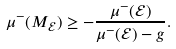<formula> <loc_0><loc_0><loc_500><loc_500>\mu ^ { - } ( M _ { \mathcal { E } } ) \geq - \frac { \mu ^ { - } ( \mathcal { E } ) } { \mu ^ { - } ( \mathcal { E } ) - g } .</formula> 